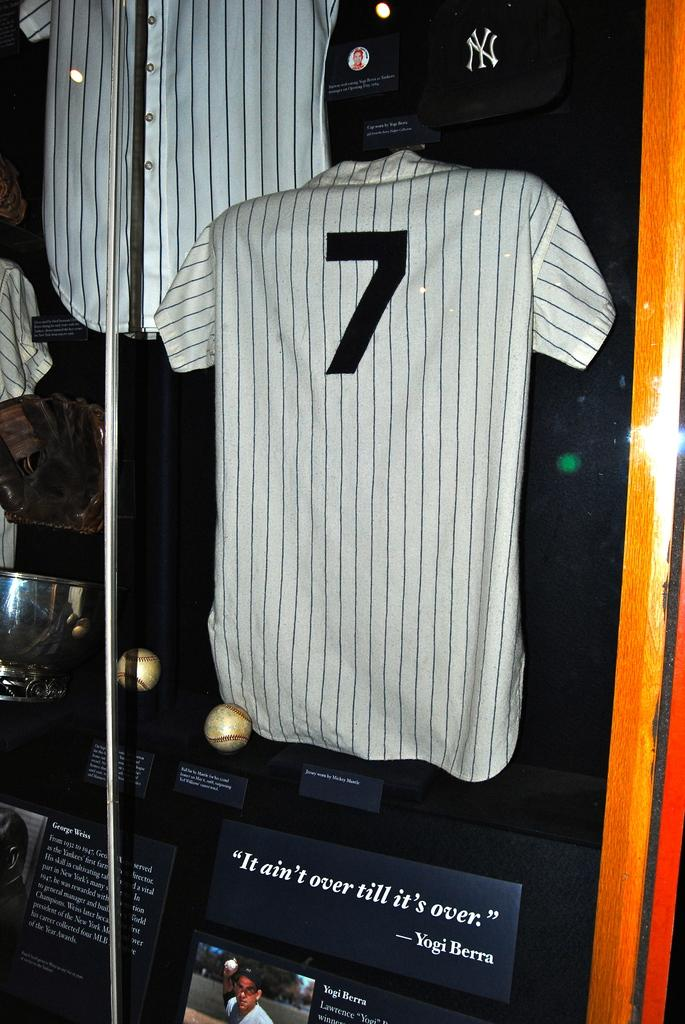<image>
Describe the image concisely. A jersey from the baseball player Yogi Berra 